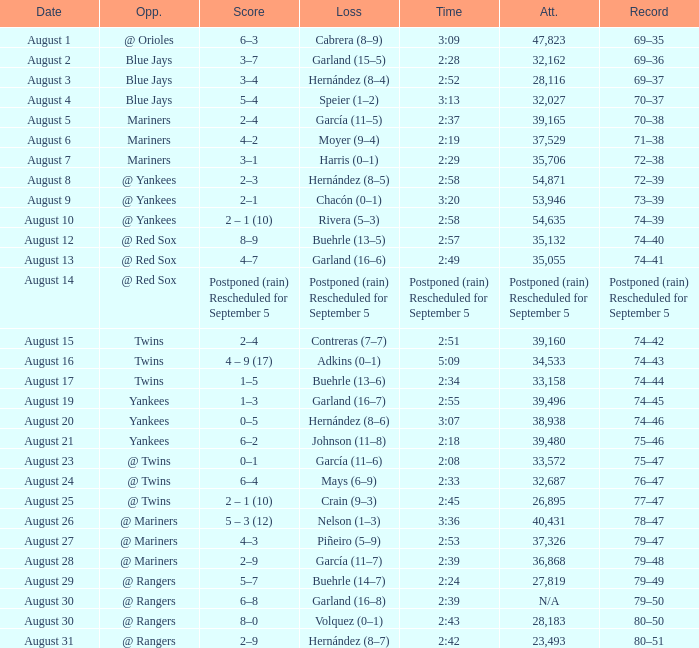Who lost on August 27? Piñeiro (5–9). 